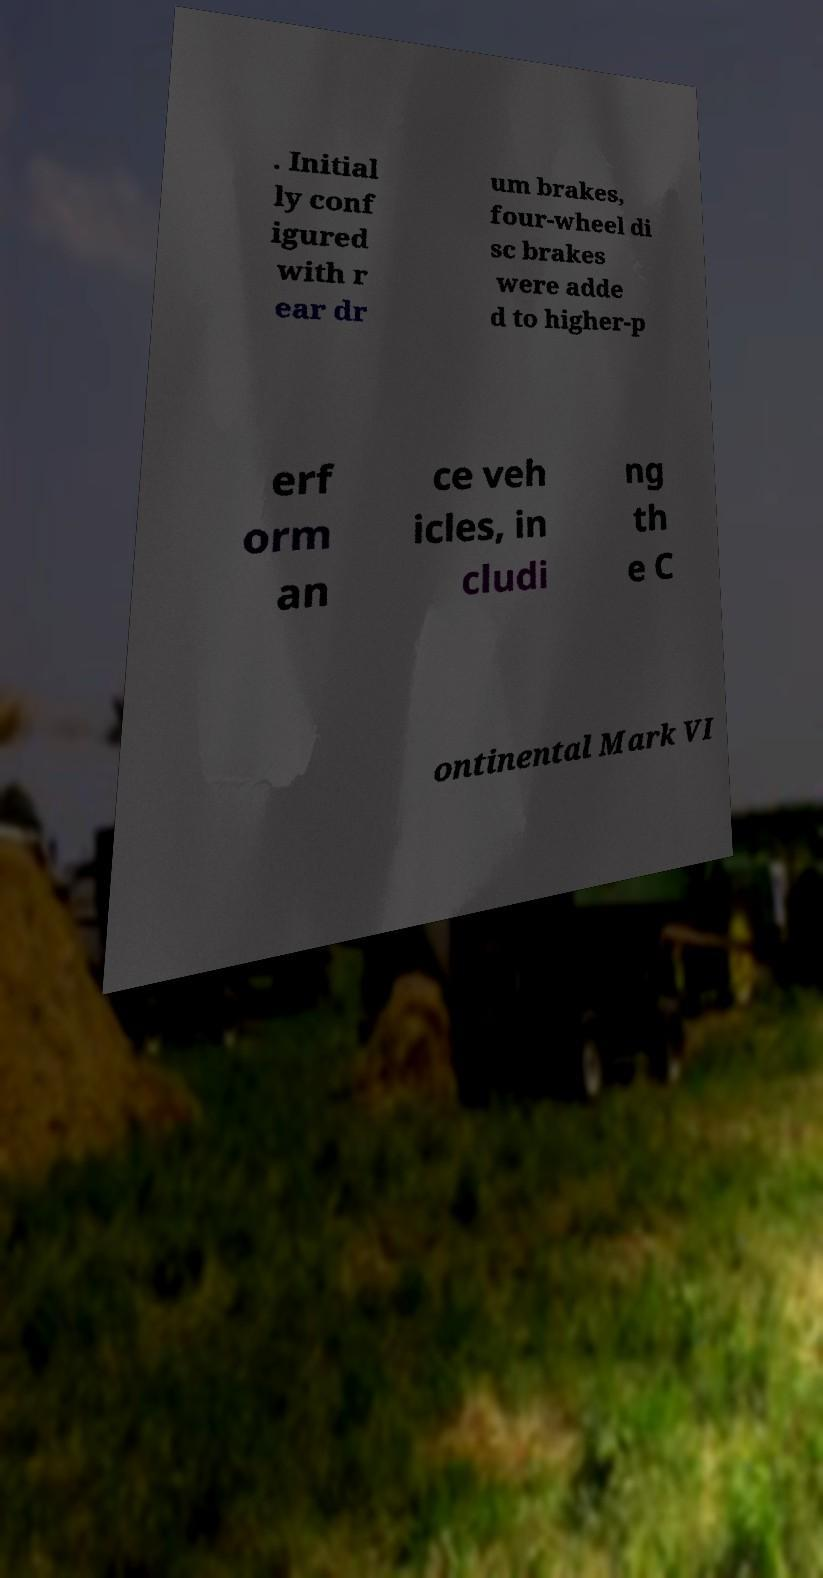There's text embedded in this image that I need extracted. Can you transcribe it verbatim? . Initial ly conf igured with r ear dr um brakes, four-wheel di sc brakes were adde d to higher-p erf orm an ce veh icles, in cludi ng th e C ontinental Mark VI 